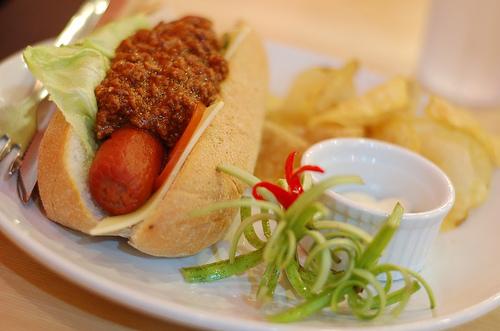Has the food on the left plate been cooked?
Answer briefly. Yes. Would you consider this to be a healthy meal?
Short answer required. No. What is the green vegetable?
Concise answer only. Lettuce. What kind of protein is on the sandwich?
Concise answer only. Beef. Is that raspberry dressing?
Short answer required. No. Is there lettuce in the hot dog?
Be succinct. Yes. What is in middle of sandwich on plate?
Concise answer only. Hot dog. What is their in the plate?
Keep it brief. Food. Are there potato chips on the plate?
Quick response, please. Yes. 